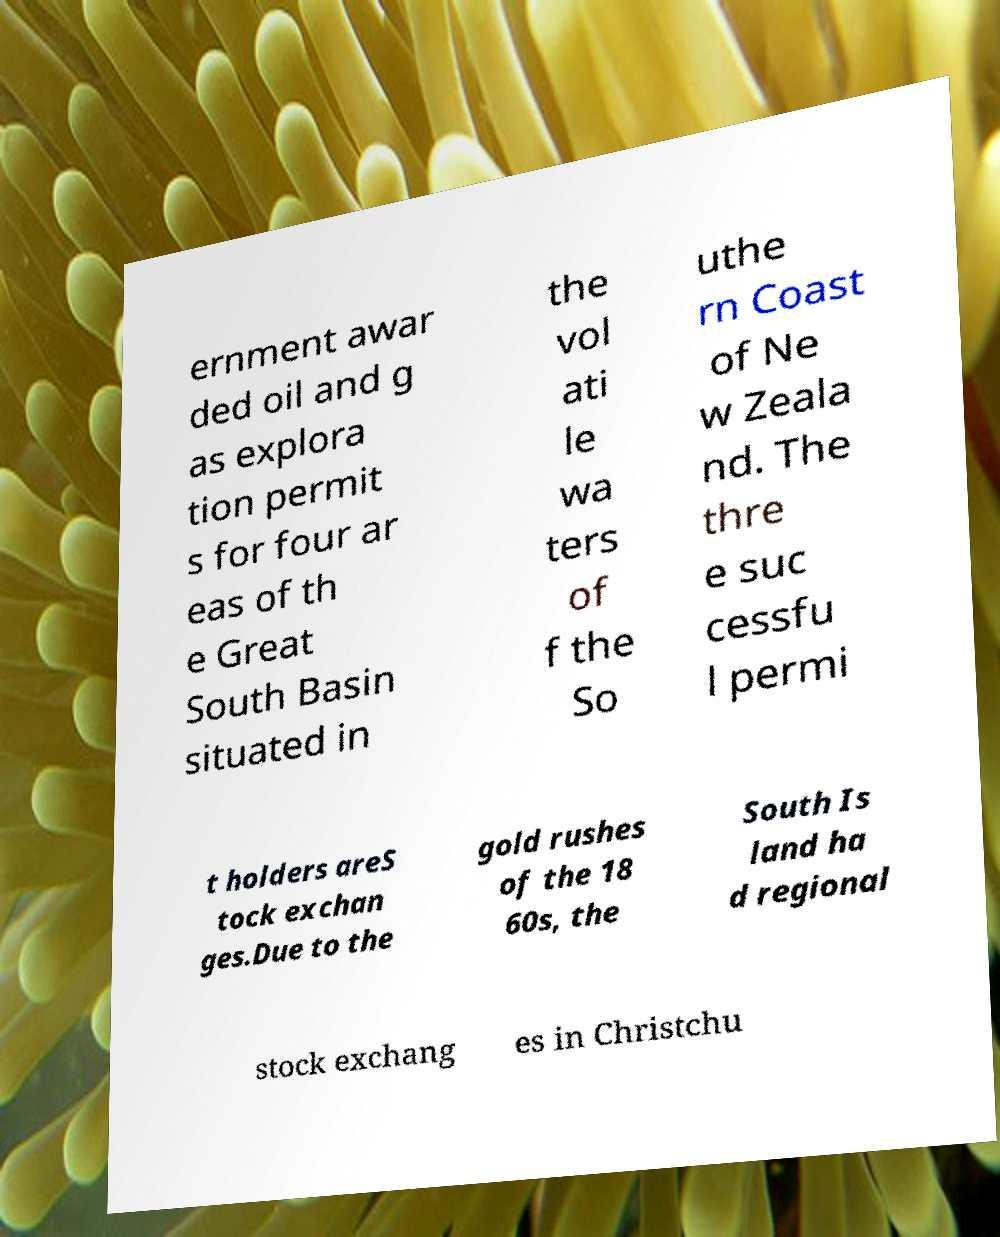Could you assist in decoding the text presented in this image and type it out clearly? ernment awar ded oil and g as explora tion permit s for four ar eas of th e Great South Basin situated in the vol ati le wa ters of f the So uthe rn Coast of Ne w Zeala nd. The thre e suc cessfu l permi t holders areS tock exchan ges.Due to the gold rushes of the 18 60s, the South Is land ha d regional stock exchang es in Christchu 